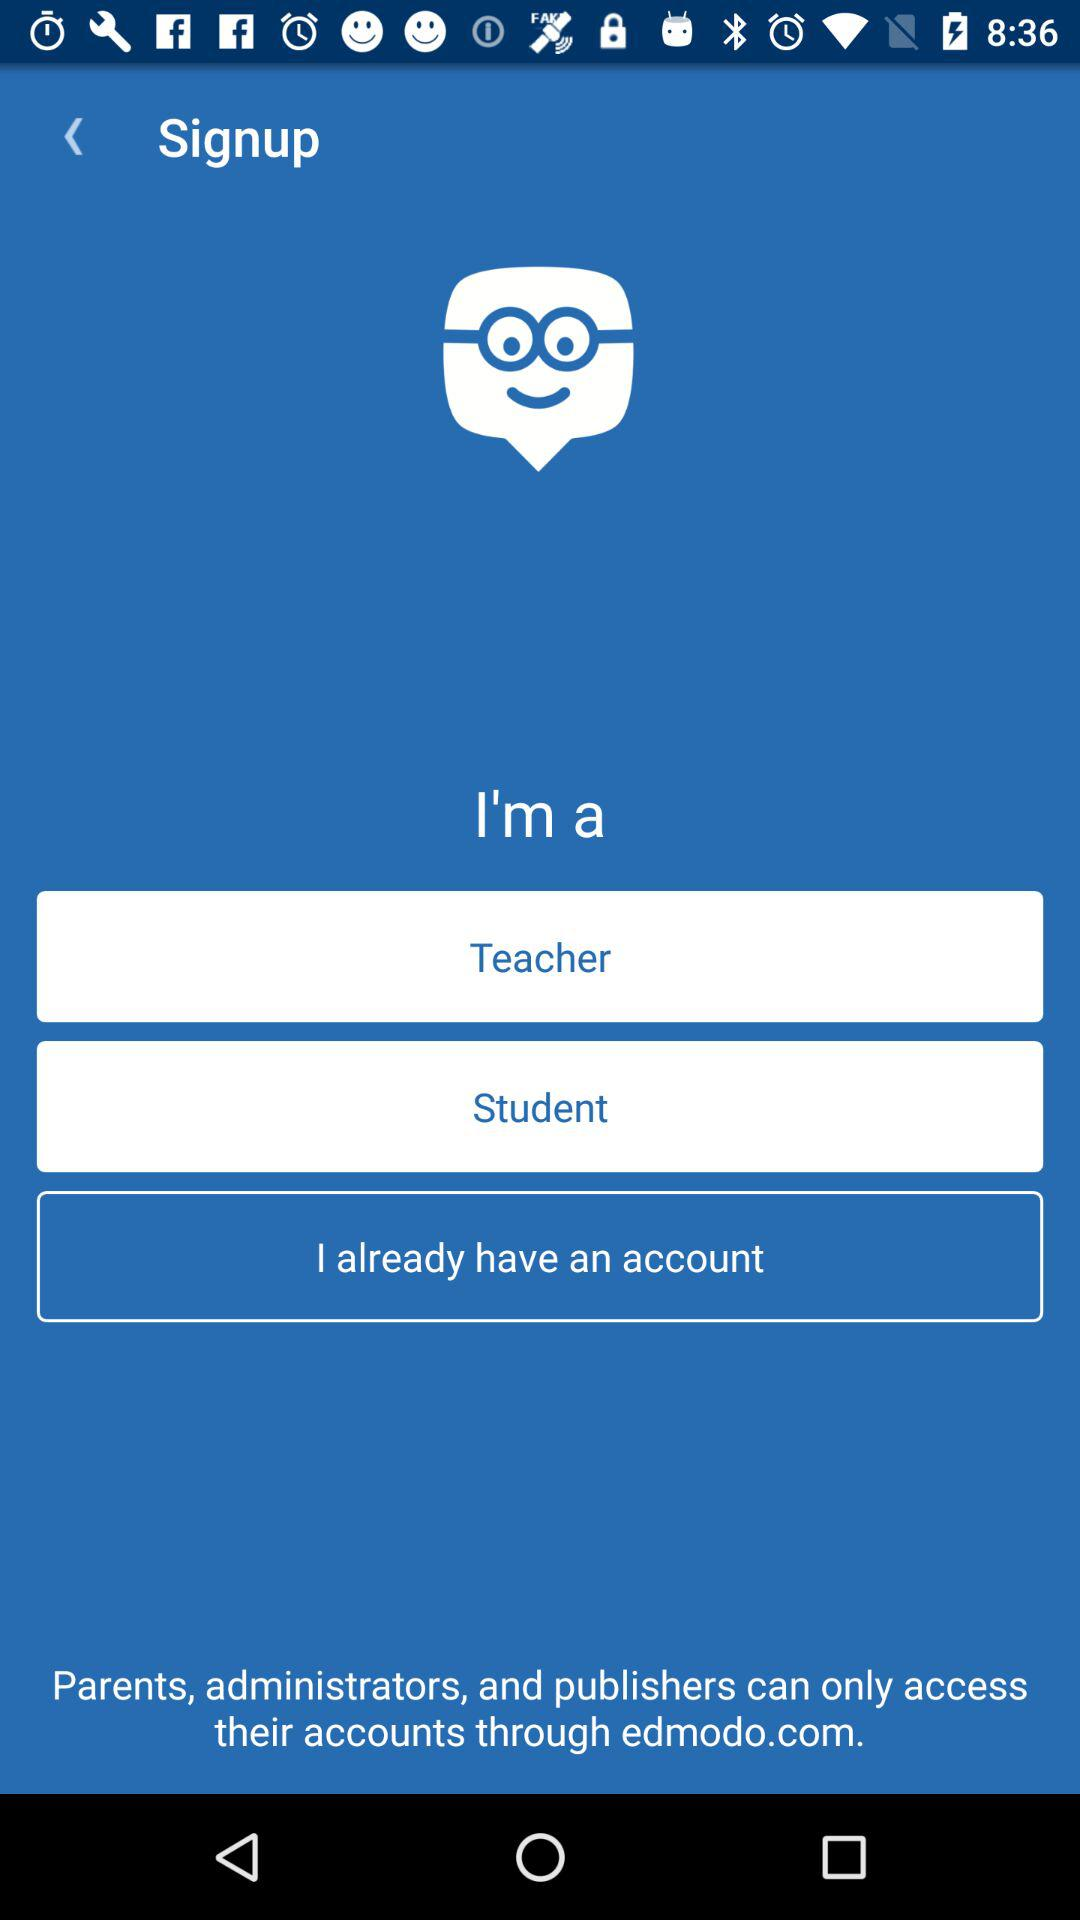What accounts can I use to sign up?
When the provided information is insufficient, respond with <no answer>. <no answer> 